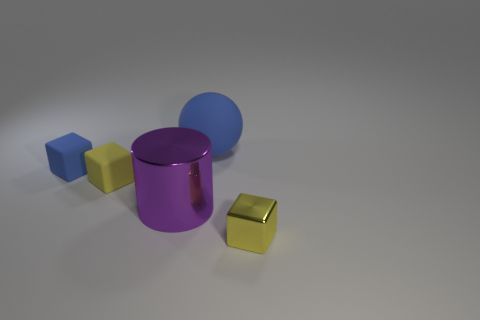There is a block that is to the left of the small yellow matte block; is its color the same as the big matte thing?
Give a very brief answer. Yes. What is the color of the other matte object that is the same shape as the yellow rubber thing?
Keep it short and to the point. Blue. Does the blue thing that is behind the blue cube have the same size as the cylinder?
Your answer should be compact. Yes. What number of big objects have the same material as the big cylinder?
Ensure brevity in your answer.  0. There is a tiny yellow cube to the right of the yellow object that is behind the tiny yellow block that is in front of the yellow rubber cube; what is its material?
Offer a terse response. Metal. There is a metallic object behind the small yellow block that is right of the big cylinder; what is its color?
Provide a short and direct response. Purple. There is a metal cylinder that is the same size as the sphere; what color is it?
Make the answer very short. Purple. What number of small objects are either purple metallic objects or red metallic cylinders?
Your answer should be compact. 0. Is the number of small yellow things in front of the big blue ball greater than the number of large metallic cylinders on the right side of the small shiny object?
Your answer should be compact. Yes. There is a rubber thing that is the same color as the large matte sphere; what size is it?
Give a very brief answer. Small. 